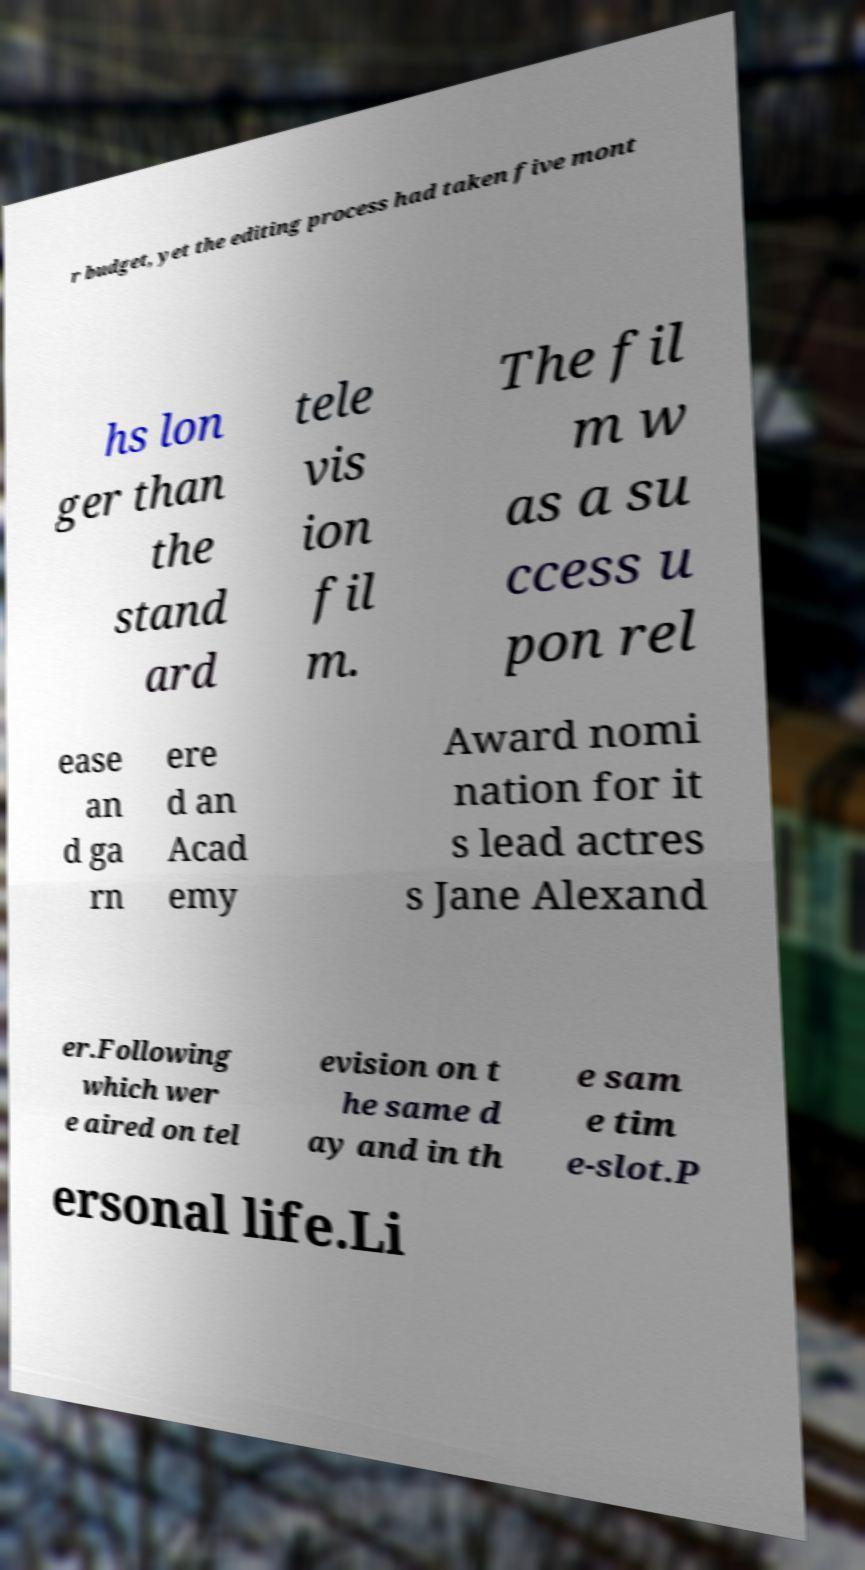What messages or text are displayed in this image? I need them in a readable, typed format. r budget, yet the editing process had taken five mont hs lon ger than the stand ard tele vis ion fil m. The fil m w as a su ccess u pon rel ease an d ga rn ere d an Acad emy Award nomi nation for it s lead actres s Jane Alexand er.Following which wer e aired on tel evision on t he same d ay and in th e sam e tim e-slot.P ersonal life.Li 